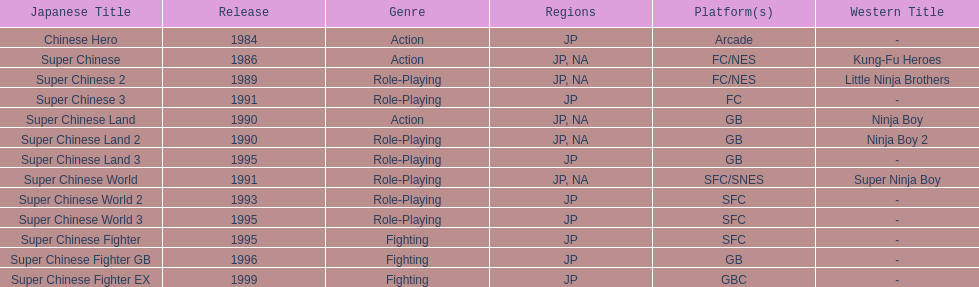What are the total of super chinese games released? 13. 